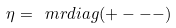<formula> <loc_0><loc_0><loc_500><loc_500>\eta = \ m r { d i a g } ( + - - - )</formula> 